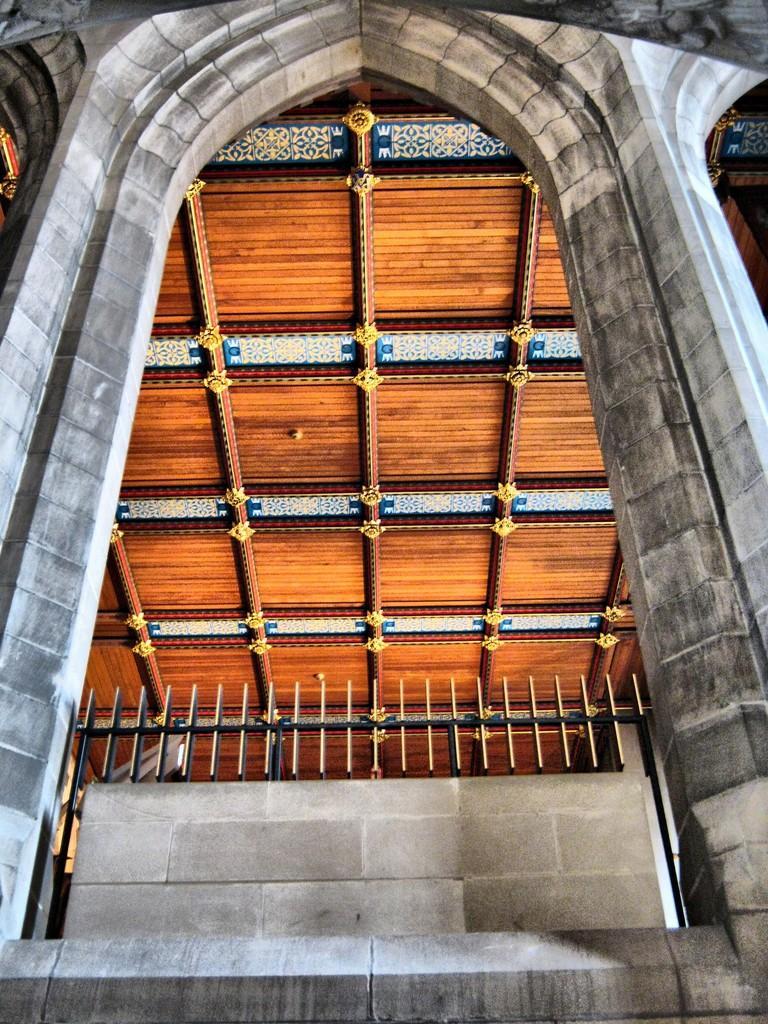Could you give a brief overview of what you see in this image? In this image I can see the building which is grey and cream in color , the railing and the ceiling which is brown, blue and cream in color. 